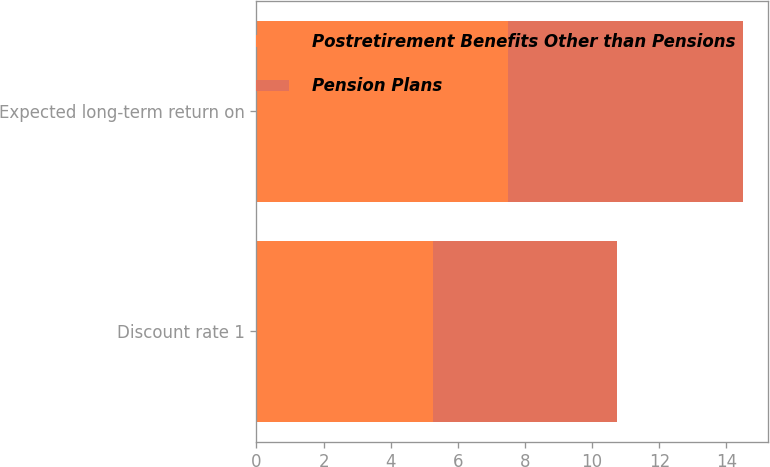<chart> <loc_0><loc_0><loc_500><loc_500><stacked_bar_chart><ecel><fcel>Discount rate 1<fcel>Expected long-term return on<nl><fcel>Postretirement Benefits Other than Pensions<fcel>5.25<fcel>7.5<nl><fcel>Pension Plans<fcel>5.5<fcel>7<nl></chart> 